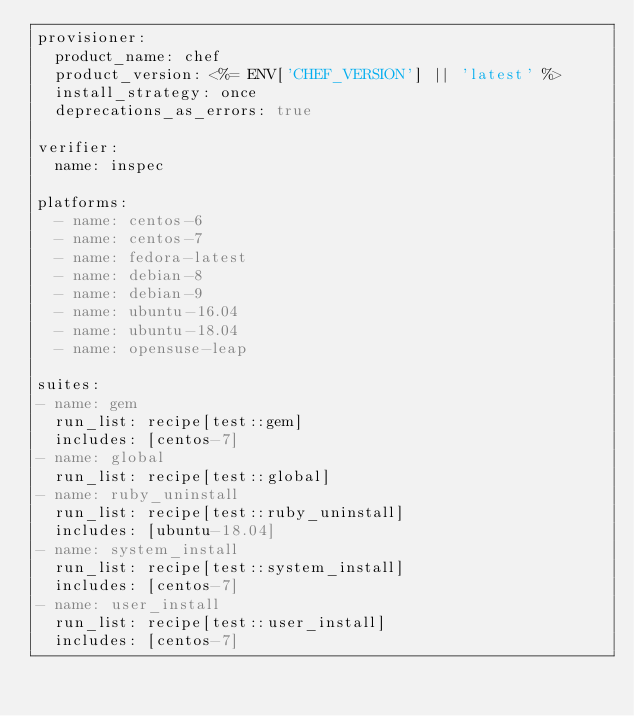<code> <loc_0><loc_0><loc_500><loc_500><_YAML_>provisioner:
  product_name: chef
  product_version: <%= ENV['CHEF_VERSION'] || 'latest' %>
  install_strategy: once
  deprecations_as_errors: true

verifier:
  name: inspec

platforms:
  - name: centos-6
  - name: centos-7
  - name: fedora-latest
  - name: debian-8
  - name: debian-9
  - name: ubuntu-16.04
  - name: ubuntu-18.04
  - name: opensuse-leap

suites:
- name: gem
  run_list: recipe[test::gem]
  includes: [centos-7]
- name: global
  run_list: recipe[test::global]
- name: ruby_uninstall
  run_list: recipe[test::ruby_uninstall]
  includes: [ubuntu-18.04]
- name: system_install
  run_list: recipe[test::system_install]
  includes: [centos-7]
- name: user_install
  run_list: recipe[test::user_install]
  includes: [centos-7]
</code> 